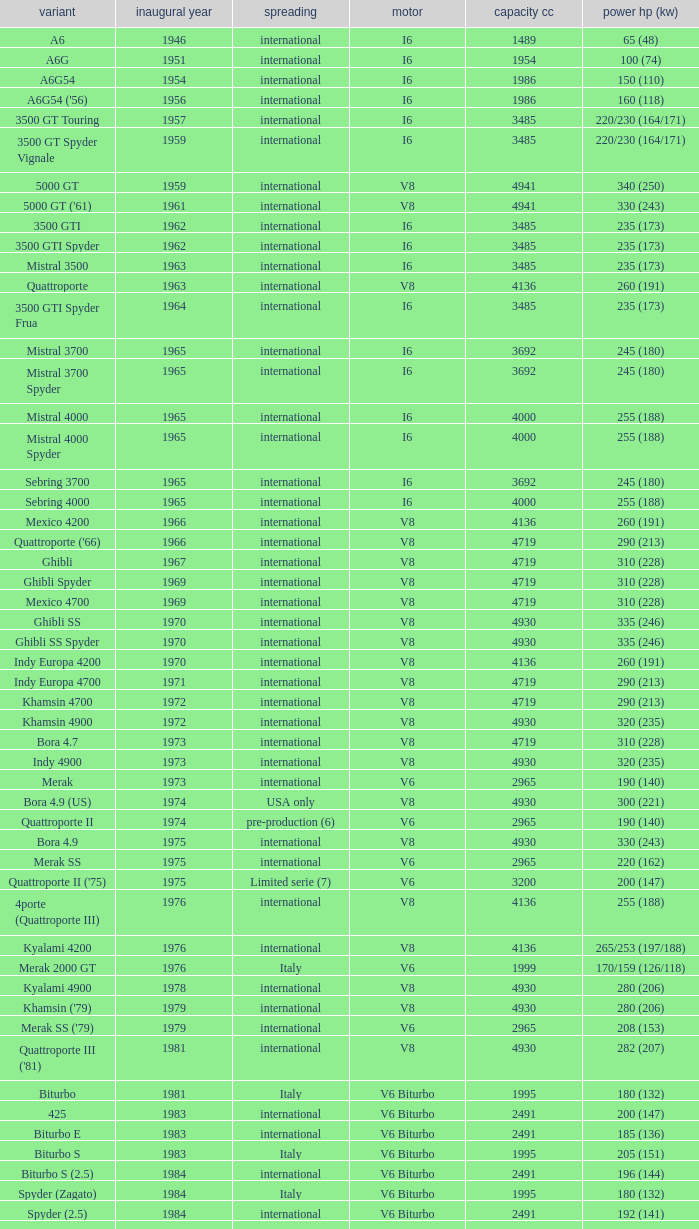What is Power HP (kW), when First Year is greater than 1965, when Distribution is "International", when Engine is V6 Biturbo, and when Model is "425"? 200 (147). 